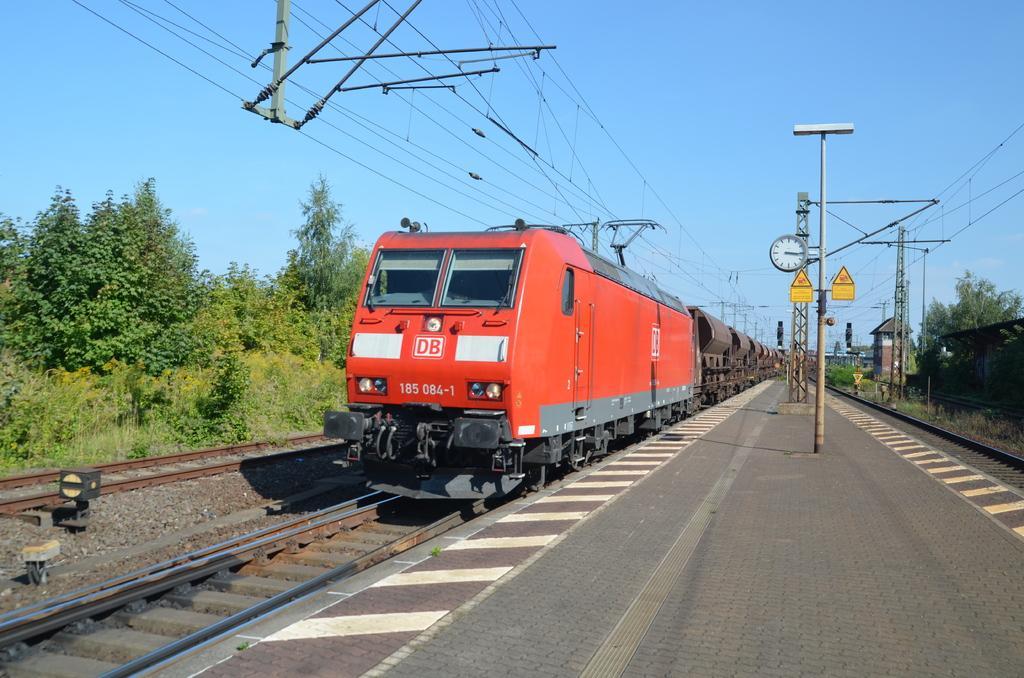In one or two sentences, can you explain what this image depicts? This image is taken in a railway station. In this image can see the train on the track. We can also see the poles, clock, stones, path and also the trees and wires. Sky is also visible in this image. 